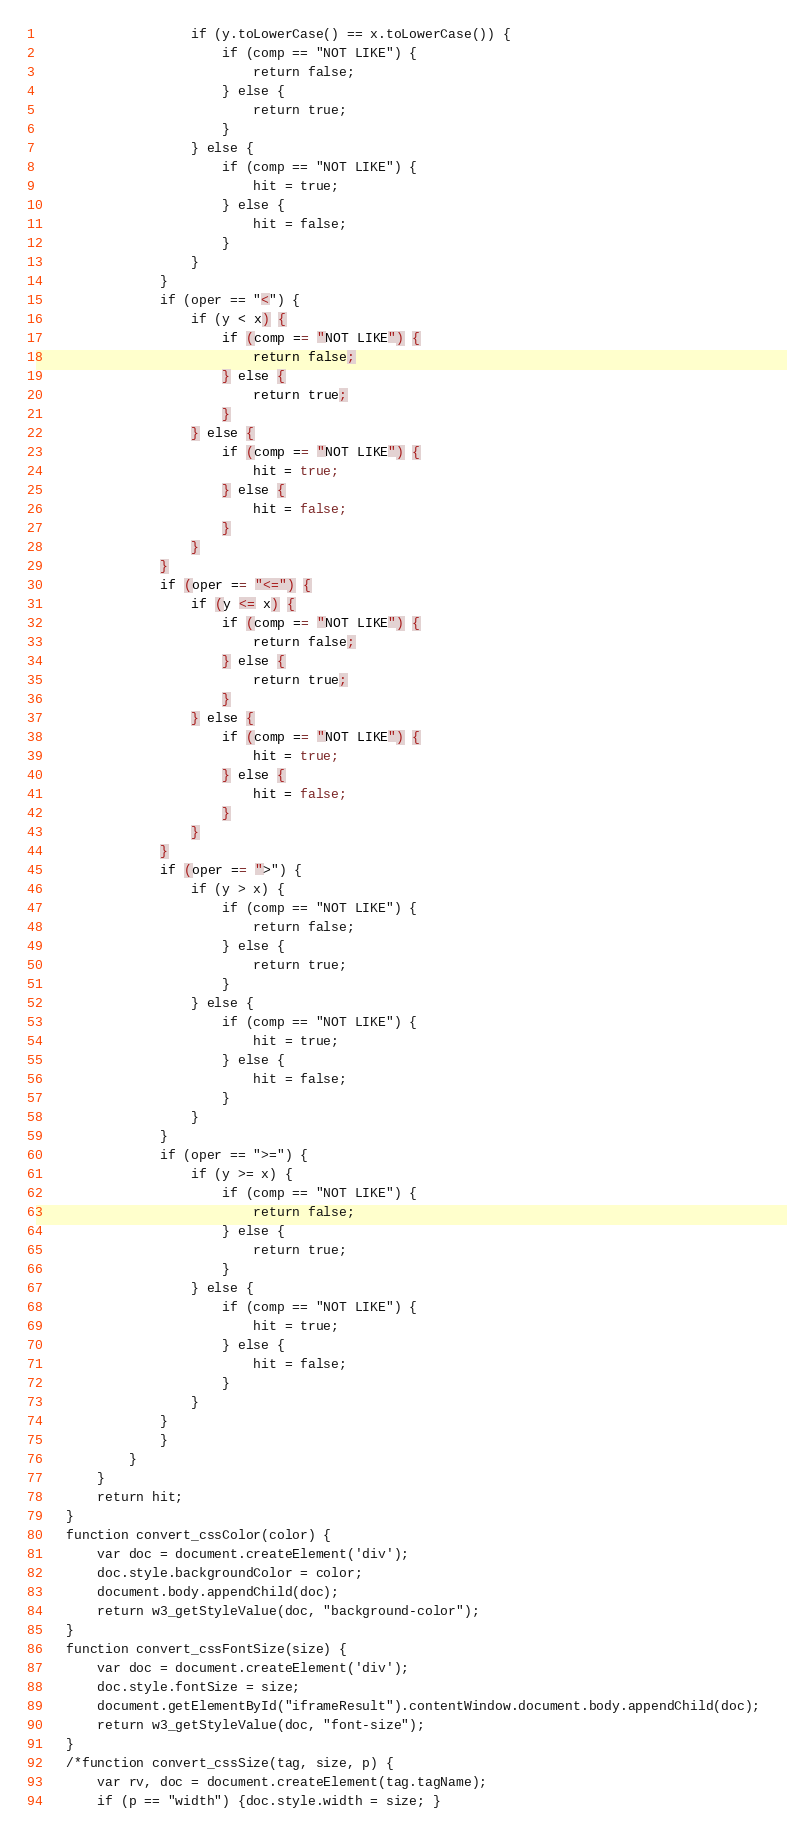<code> <loc_0><loc_0><loc_500><loc_500><_HTML_>                    if (y.toLowerCase() == x.toLowerCase()) {
                        if (comp == "NOT LIKE") {
                            return false;
                        } else {
                            return true;
                        }
                    } else {
                        if (comp == "NOT LIKE") {
                            hit = true;
                        } else {
                            hit = false;
                        }
                    }
                }
                if (oper == "<") {
                    if (y < x) {
                        if (comp == "NOT LIKE") {
                            return false;
                        } else {
                            return true;
                        }
                    } else {
                        if (comp == "NOT LIKE") {
                            hit = true;
                        } else {
                            hit = false;
                        }
                    }
                }
                if (oper == "<=") {
                    if (y <= x) {
                        if (comp == "NOT LIKE") {
                            return false;
                        } else {
                            return true;
                        }
                    } else {
                        if (comp == "NOT LIKE") {
                            hit = true;
                        } else {
                            hit = false;
                        }
                    }
                }
                if (oper == ">") {
                    if (y > x) {
                        if (comp == "NOT LIKE") {
                            return false;
                        } else {
                            return true;
                        }
                    } else {
                        if (comp == "NOT LIKE") {
                            hit = true;
                        } else {
                            hit = false;
                        }
                    }
                }
                if (oper == ">=") {
                    if (y >= x) {
                        if (comp == "NOT LIKE") {
                            return false;
                        } else {
                            return true;
                        }
                    } else {
                        if (comp == "NOT LIKE") {
                            hit = true;
                        } else {
                            hit = false;
                        }
                    }
                }                
                }
            }
        }
        return hit;
    }
    function convert_cssColor(color) {
        var doc = document.createElement('div');
        doc.style.backgroundColor = color;
        document.body.appendChild(doc);
        return w3_getStyleValue(doc, "background-color");
    }
    function convert_cssFontSize(size) {
        var doc = document.createElement('div');
        doc.style.fontSize = size;
        document.getElementById("iframeResult").contentWindow.document.body.appendChild(doc);
        return w3_getStyleValue(doc, "font-size");
    }
    /*function convert_cssSize(tag, size, p) {
        var rv, doc = document.createElement(tag.tagName);
        if (p == "width") {doc.style.width = size; }</code> 